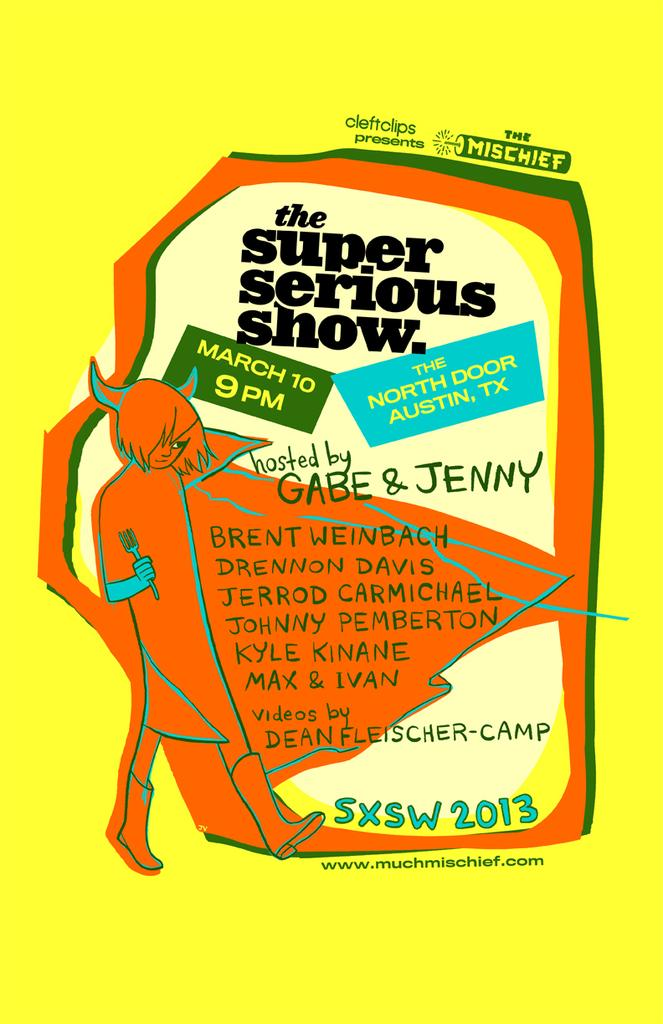<image>
Write a terse but informative summary of the picture. A poster is displayed for The Super Serious Show on March 10 